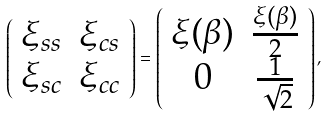<formula> <loc_0><loc_0><loc_500><loc_500>\left ( \begin{array} { c c } \xi _ { s s } & \xi _ { c s } \\ \xi _ { s c } & \xi _ { c c } \end{array} \right ) = \left ( \begin{array} { c c } \xi ( \beta ) & \frac { \xi ( \beta ) } { 2 } \\ 0 & \frac { 1 } { \sqrt { 2 } } \end{array} \right ) ,</formula> 